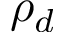Convert formula to latex. <formula><loc_0><loc_0><loc_500><loc_500>\rho _ { d }</formula> 